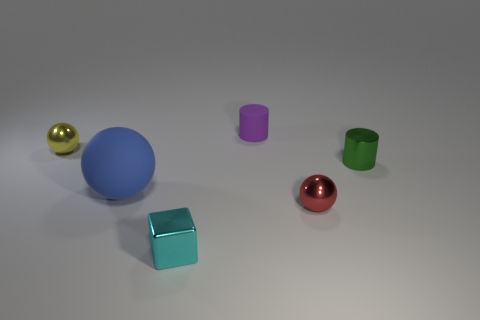Is there anything else that is the same size as the blue ball?
Offer a terse response. No. Is the number of tiny spheres right of the tiny green cylinder the same as the number of tiny brown rubber objects?
Offer a very short reply. Yes. How big is the shiny object that is both behind the metal block and left of the purple rubber cylinder?
Provide a short and direct response. Small. The tiny metallic thing right of the small metal sphere right of the tiny rubber object is what color?
Offer a very short reply. Green. How many blue things are rubber spheres or tiny blocks?
Ensure brevity in your answer.  1. There is a tiny metal thing that is both behind the cube and to the left of the purple rubber object; what is its color?
Provide a short and direct response. Yellow. What number of large objects are green things or yellow metal spheres?
Offer a terse response. 0. What is the size of the other shiny object that is the same shape as the tiny red thing?
Make the answer very short. Small. What is the shape of the cyan object?
Offer a very short reply. Cube. Does the green cylinder have the same material as the small cylinder that is on the left side of the red metallic object?
Provide a short and direct response. No. 